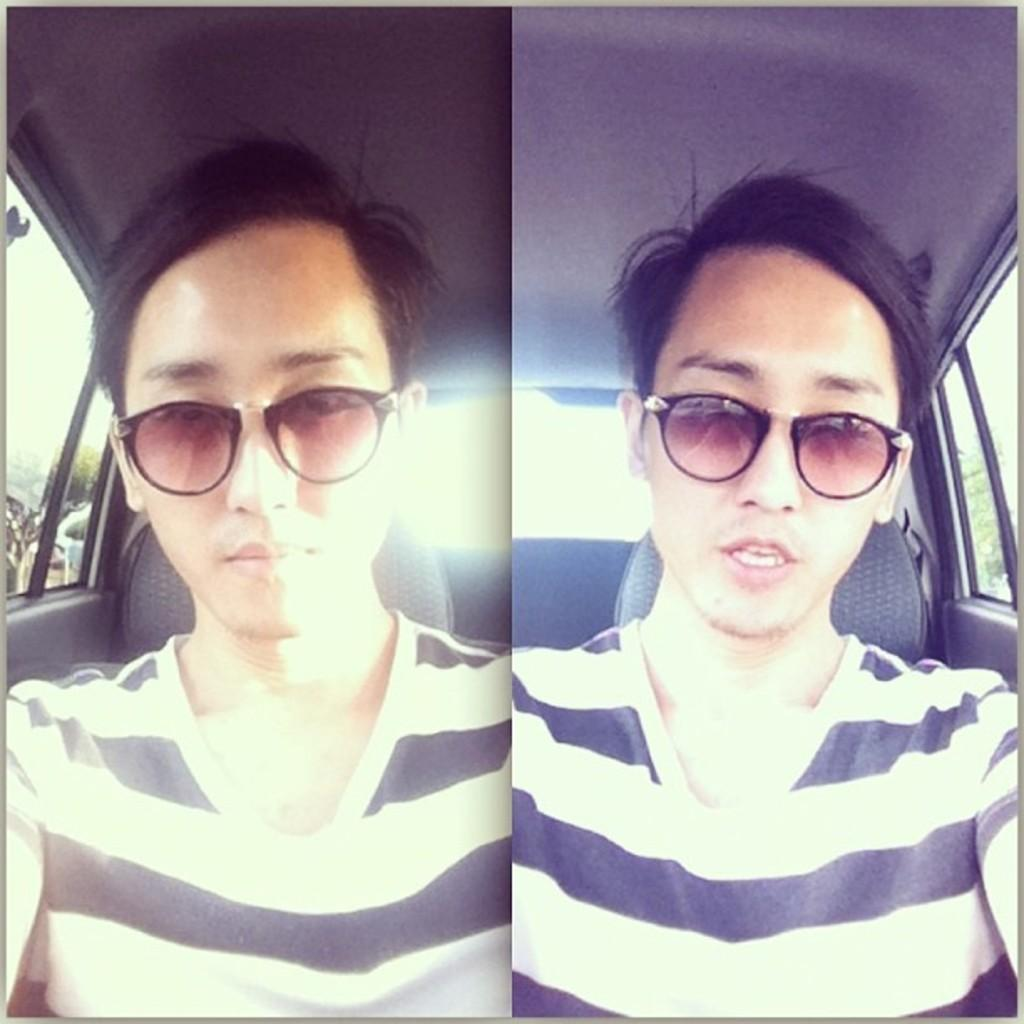What is the main subject of the image? The main subject of the image is a collage of photos. What can be seen in the photos within the collage? The photos depict a person sitting in a vehicle. What is the person wearing in the photos? The person in the photos is wearing goggles. What type of lettuce can be seen growing in the background of the photos? There is no lettuce visible in the background of the photos; the focus is on the person sitting in the vehicle and wearing goggles. 